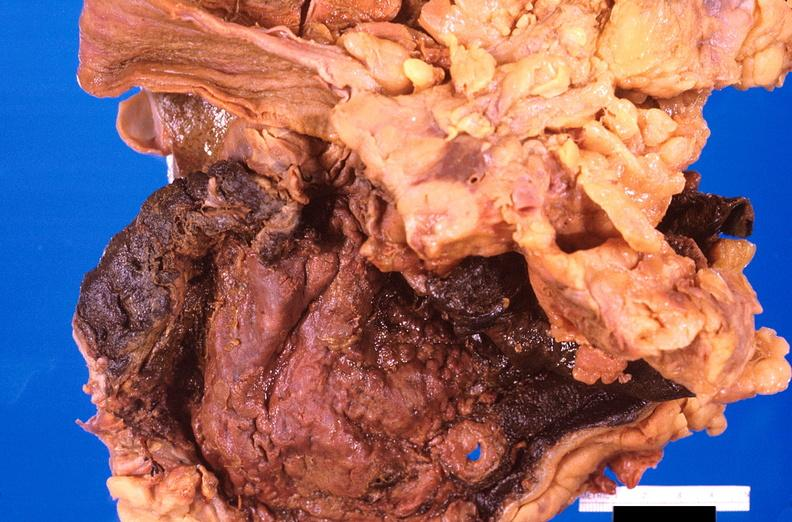s gastrointestinal present?
Answer the question using a single word or phrase. Yes 